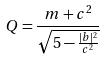<formula> <loc_0><loc_0><loc_500><loc_500>Q = \frac { m + c ^ { 2 } } { \sqrt { 5 - \frac { | b | ^ { 2 } } { c ^ { 2 } } } }</formula> 